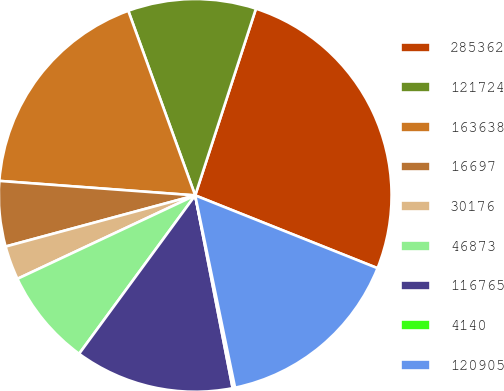<chart> <loc_0><loc_0><loc_500><loc_500><pie_chart><fcel>285362<fcel>121724<fcel>163638<fcel>16697<fcel>30176<fcel>46873<fcel>116765<fcel>4140<fcel>120905<nl><fcel>26.04%<fcel>10.54%<fcel>18.29%<fcel>5.37%<fcel>2.79%<fcel>7.95%<fcel>13.12%<fcel>0.2%<fcel>15.7%<nl></chart> 